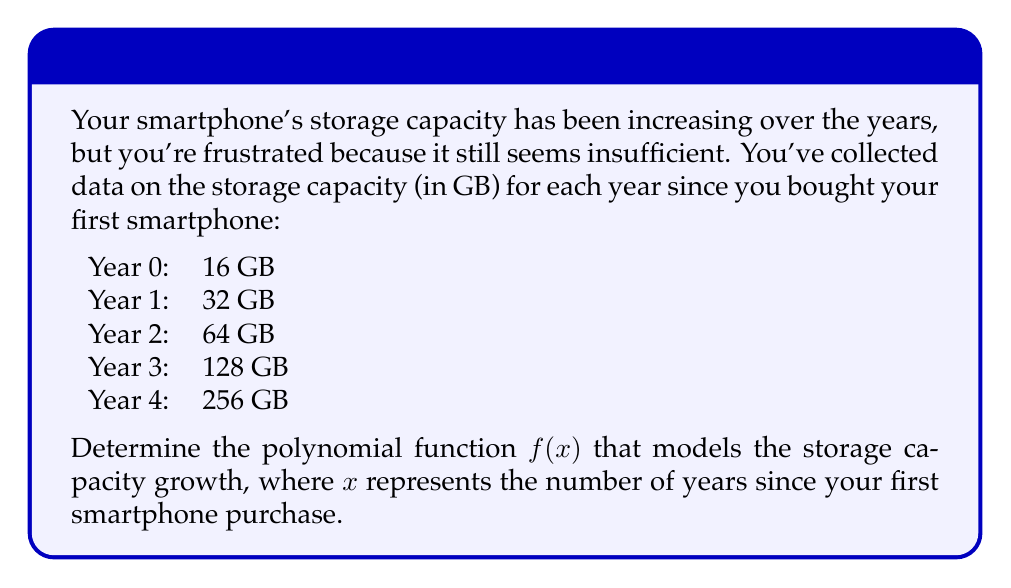Help me with this question. To find the polynomial function that fits this data, we can use the method of finite differences:

1. Calculate the differences between consecutive terms:
   1st differences: 16, 32, 64, 128
   2nd differences: 16, 32, 64
   3rd differences: 16, 32
   4th differences: 16

2. Since the 4th differences are constant, we know this is a 4th-degree polynomial.

3. The general form of a 4th-degree polynomial is:
   $$f(x) = ax^4 + bx^3 + cx^2 + dx + e$$

4. To find the coefficients, we use the following formulas:
   $$a = \frac{4\text{th difference}}{4!} = \frac{16}{24} = \frac{2}{3}$$
   $$b = \frac{3\text{rd difference at } x=0}{3!} = \frac{16}{6} = \frac{8}{3}$$
   $$c = \frac{2\text{nd difference at } x=0}{2!} = \frac{16}{2} = 8$$
   $$d = \text{1st difference at } x=0 = 16$$
   $$e = f(0) = 16$$

5. Substituting these values into the general form:
   $$f(x) = \frac{2}{3}x^4 + \frac{8}{3}x^3 + 8x^2 + 16x + 16$$

6. To verify, we can check if this function produces the correct values for each year:
   Year 0: $f(0) = 16$
   Year 1: $f(1) = \frac{2}{3} + \frac{8}{3} + 8 + 16 + 16 = 32$
   Year 2: $f(2) = \frac{32}{3} + \frac{64}{3} + 32 + 32 + 16 = 64$
   Year 3: $f(3) = 54 + 72 + 72 + 48 + 16 = 128$
   Year 4: $f(4) = 170\frac{2}{3} + 170\frac{2}{3} + 128 + 64 + 16 = 256$
Answer: The polynomial function modeling the storage capacity growth is:
$$f(x) = \frac{2}{3}x^4 + \frac{8}{3}x^3 + 8x^2 + 16x + 16$$
where $x$ represents the number of years since the first smartphone purchase. 